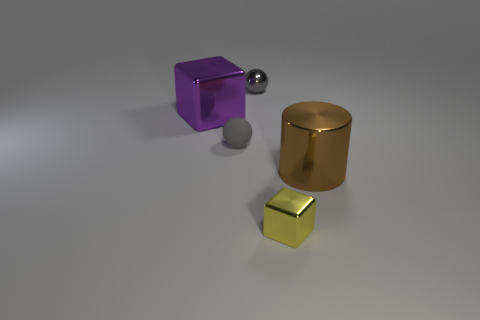Subtract all balls. How many objects are left? 3 Subtract all yellow cubes. How many cubes are left? 1 Add 3 small metal balls. How many objects exist? 8 Subtract all big gray metallic cubes. Subtract all balls. How many objects are left? 3 Add 1 brown metallic cylinders. How many brown metallic cylinders are left? 2 Add 1 large green balls. How many large green balls exist? 1 Subtract 0 red cubes. How many objects are left? 5 Subtract 2 spheres. How many spheres are left? 0 Subtract all purple blocks. Subtract all blue cylinders. How many blocks are left? 1 Subtract all brown cylinders. How many blue cubes are left? 0 